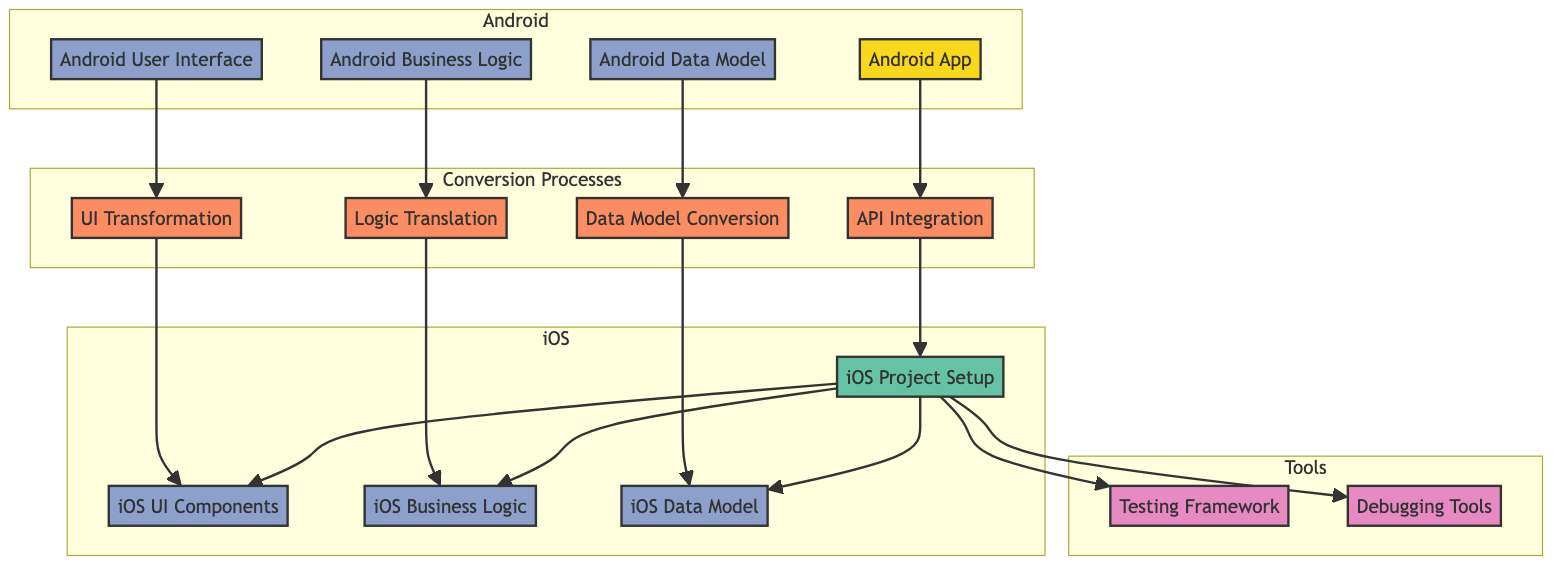What is the total number of components in the diagram? Counting all listed components—Android User Interface, Android Business Logic, Android Data Model, iOS UI Components, iOS Business Logic, and iOS Data Model—there are a total of six components on the iOS side and four on the Android side, leading to a total of ten components in the diagram.
Answer: ten What process is responsible for converting Android UI components? Examining the diagram, the arrow leads from the Android User Interface to UI Transformation, indicating that UI Transformation is the process responsible for converting Android UI components to iOS equivalents.
Answer: UI Transformation How many tools are included in the diagram? The tools listed in the diagram are the Testing Framework and Debugging Tools. Therefore, counting these gives a total of two tools present in the diagram.
Answer: two What component does Logic Translation connect to? Tracing the flow in the diagram, Logic Translation has a one-way connection to iOS Business Logic, which indicates that the output of Logic Translation feeds into this component.
Answer: iOS Business Logic Which process derives from the Android Data Model? The connection from Android Data Model points to Data Model Conversion in the diagram, indicating that Data Model Conversion is the process derived from the Android Data Model.
Answer: Data Model Conversion What is the first component in the iOS section after API Integration? Looking at the flow from API Integration, the next component it connects to is iOS Project Setup, which makes it the first component in the iOS section following API Integration.
Answer: iOS Project Setup Which component is the source at the top of the diagram? The diagram indicates that the source at the top is the Android App, as it is labeled as the first component and is highlighted as the source type.
Answer: Android App What is the final destination after the conversion processes? Tracing the paths from all conversion processes, they all lead to the iOS Project Setup component, which is the final destination of these processes before testing and debugging.
Answer: iOS Project Setup Which component is responsible for diagnosing issues during conversion? Within the tools section of the diagram, the Debugging Tools component is explicitly labeled to be responsible for diagnosing issues, confirming its role in the conversion process.
Answer: Debugging Tools 